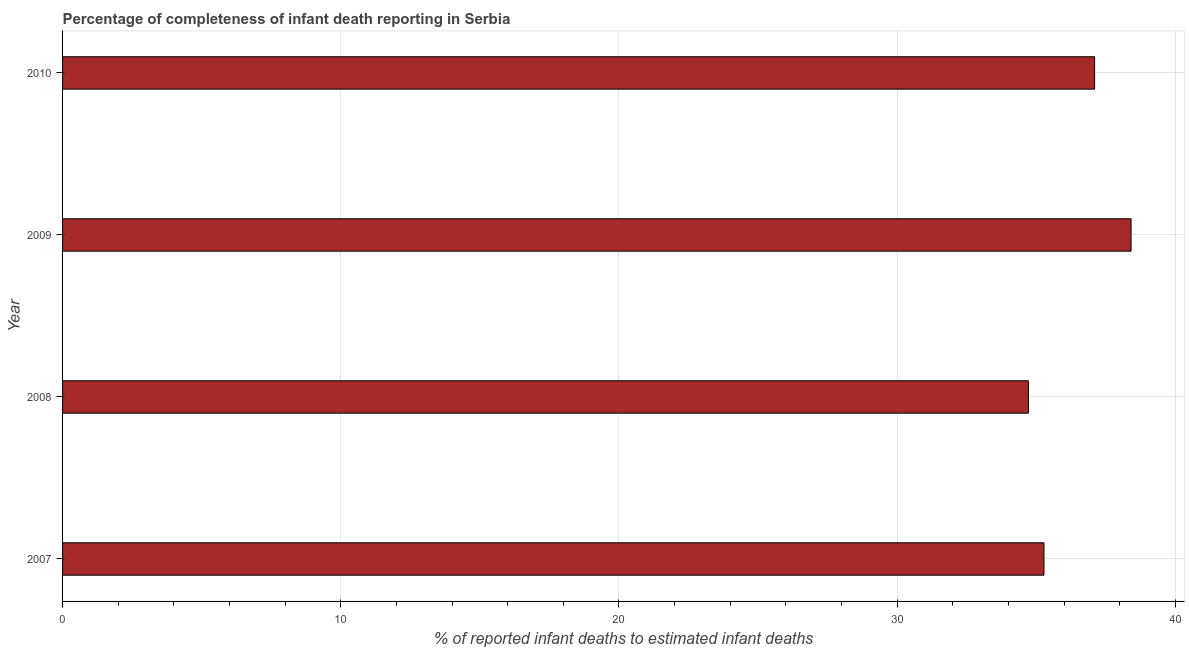Does the graph contain grids?
Provide a short and direct response. Yes. What is the title of the graph?
Keep it short and to the point. Percentage of completeness of infant death reporting in Serbia. What is the label or title of the X-axis?
Keep it short and to the point. % of reported infant deaths to estimated infant deaths. What is the label or title of the Y-axis?
Keep it short and to the point. Year. What is the completeness of infant death reporting in 2009?
Your answer should be compact. 38.41. Across all years, what is the maximum completeness of infant death reporting?
Ensure brevity in your answer.  38.41. Across all years, what is the minimum completeness of infant death reporting?
Provide a short and direct response. 34.72. In which year was the completeness of infant death reporting minimum?
Provide a succinct answer. 2008. What is the sum of the completeness of infant death reporting?
Ensure brevity in your answer.  145.5. What is the difference between the completeness of infant death reporting in 2007 and 2008?
Ensure brevity in your answer.  0.56. What is the average completeness of infant death reporting per year?
Offer a very short reply. 36.38. What is the median completeness of infant death reporting?
Offer a terse response. 36.19. What is the ratio of the completeness of infant death reporting in 2007 to that in 2010?
Your answer should be very brief. 0.95. Is the completeness of infant death reporting in 2008 less than that in 2010?
Your answer should be compact. Yes. What is the difference between the highest and the second highest completeness of infant death reporting?
Give a very brief answer. 1.31. Is the sum of the completeness of infant death reporting in 2007 and 2010 greater than the maximum completeness of infant death reporting across all years?
Provide a succinct answer. Yes. What is the difference between the highest and the lowest completeness of infant death reporting?
Give a very brief answer. 3.69. Are all the bars in the graph horizontal?
Keep it short and to the point. Yes. How many years are there in the graph?
Provide a succinct answer. 4. Are the values on the major ticks of X-axis written in scientific E-notation?
Your answer should be compact. No. What is the % of reported infant deaths to estimated infant deaths of 2007?
Make the answer very short. 35.28. What is the % of reported infant deaths to estimated infant deaths of 2008?
Offer a very short reply. 34.72. What is the % of reported infant deaths to estimated infant deaths of 2009?
Your response must be concise. 38.41. What is the % of reported infant deaths to estimated infant deaths in 2010?
Offer a very short reply. 37.1. What is the difference between the % of reported infant deaths to estimated infant deaths in 2007 and 2008?
Offer a very short reply. 0.56. What is the difference between the % of reported infant deaths to estimated infant deaths in 2007 and 2009?
Provide a succinct answer. -3.13. What is the difference between the % of reported infant deaths to estimated infant deaths in 2007 and 2010?
Your answer should be compact. -1.82. What is the difference between the % of reported infant deaths to estimated infant deaths in 2008 and 2009?
Your answer should be very brief. -3.69. What is the difference between the % of reported infant deaths to estimated infant deaths in 2008 and 2010?
Your response must be concise. -2.38. What is the difference between the % of reported infant deaths to estimated infant deaths in 2009 and 2010?
Provide a short and direct response. 1.31. What is the ratio of the % of reported infant deaths to estimated infant deaths in 2007 to that in 2009?
Give a very brief answer. 0.92. What is the ratio of the % of reported infant deaths to estimated infant deaths in 2007 to that in 2010?
Make the answer very short. 0.95. What is the ratio of the % of reported infant deaths to estimated infant deaths in 2008 to that in 2009?
Your response must be concise. 0.9. What is the ratio of the % of reported infant deaths to estimated infant deaths in 2008 to that in 2010?
Provide a short and direct response. 0.94. What is the ratio of the % of reported infant deaths to estimated infant deaths in 2009 to that in 2010?
Your answer should be compact. 1.03. 